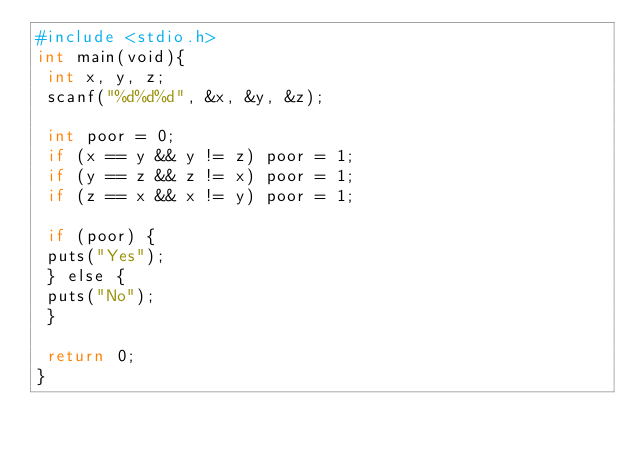Convert code to text. <code><loc_0><loc_0><loc_500><loc_500><_Awk_>#include <stdio.h>
int main(void){
 int x, y, z;
 scanf("%d%d%d", &x, &y, &z);

 int poor = 0;
 if (x == y && y != z) poor = 1;
 if (y == z && z != x) poor = 1;
 if (z == x && x != y) poor = 1;

 if (poor) {
 puts("Yes");
 } else {
 puts("No");
 }

 return 0;
}</code> 